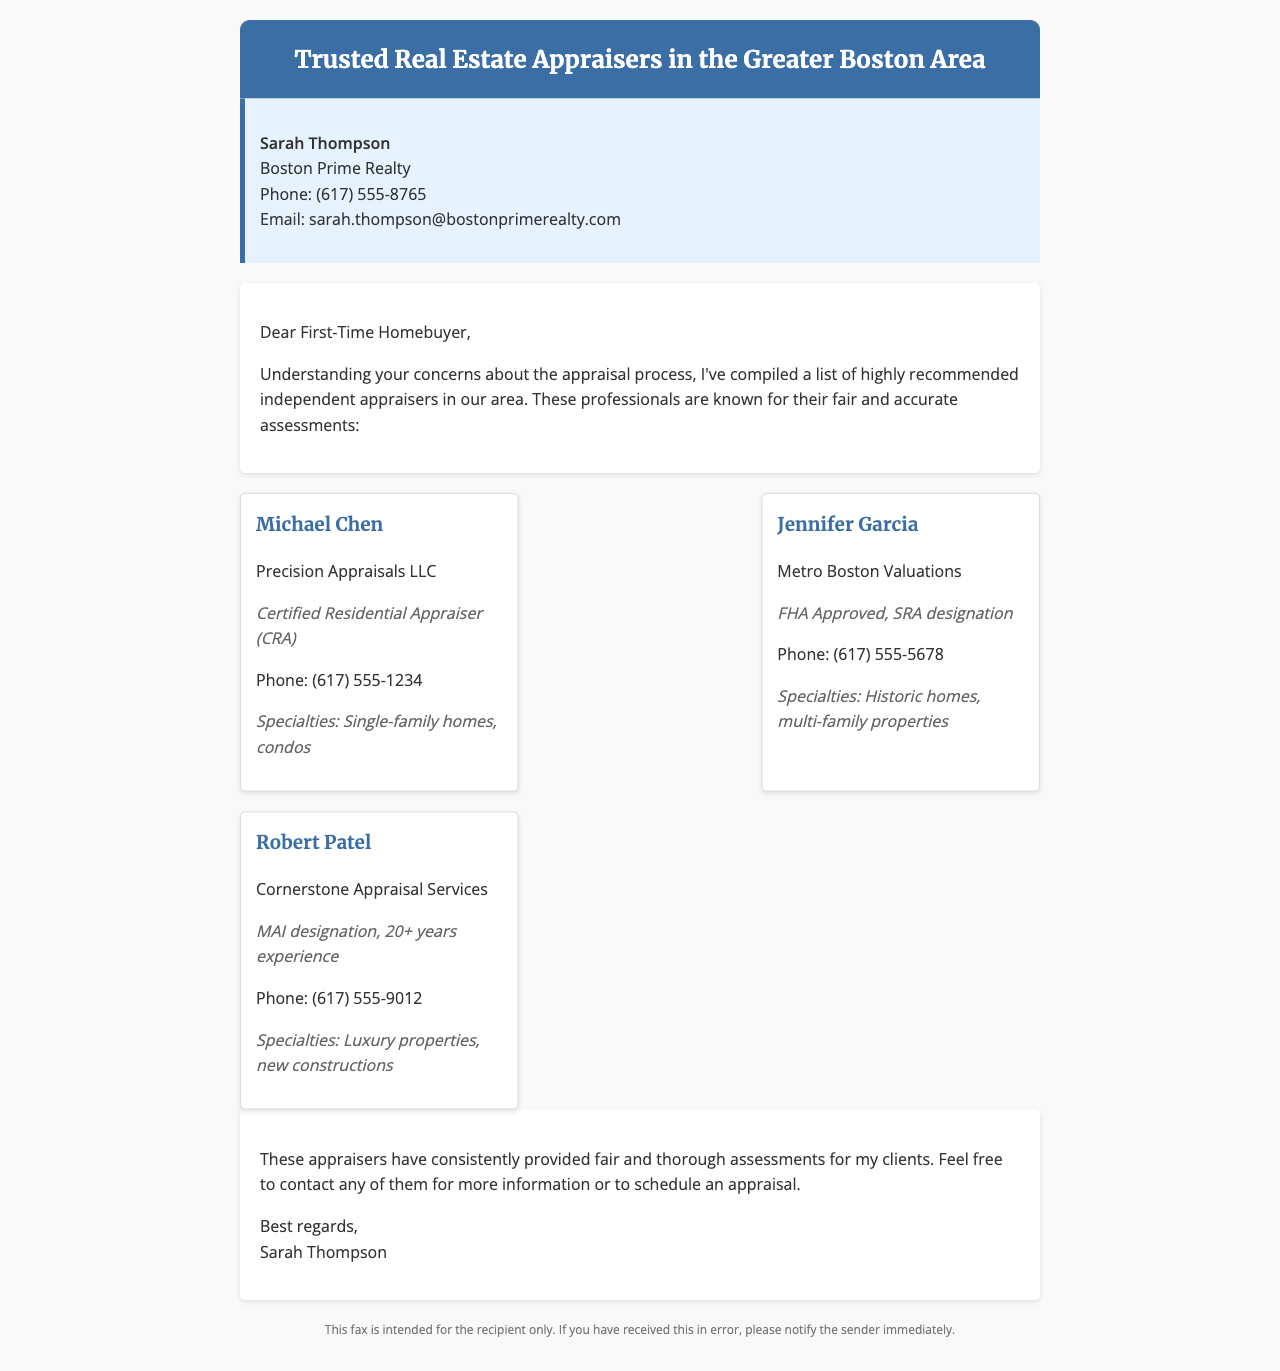What is the title of the document? The title of the document is mentioned in the header, indicating the subject of the fax.
Answer: Trusted Real Estate Appraisers in the Greater Boston Area Who is the real estate agent? The document identifies the person who provided the appraiser list.
Answer: Sarah Thompson What is the phone number for Michael Chen? The document lists contact information for each appraiser.
Answer: (617) 555-1234 What is Jennifer Garcia's specialty? The specialties of the appraisers are noted in their respective sections.
Answer: Historic homes, multi-family properties How many years of experience does Robert Patel have? The document mentions the experience level of Robert Patel as part of his credentials.
Answer: 20+ years What is the company name for Robert Patel? The document specifies the business each appraiser is associated with.
Answer: Cornerstone Appraisal Services What designation does Jennifer Garcia hold? The document provides specific credentials for each appraiser.
Answer: FHA Approved, SRA designation What is the purpose of this fax? The purpose is stated in the introductory text of the document.
Answer: To provide a list of recommended independent appraisers What kind of properties does Michael Chen specialize in? The specialties section provides information on the types of properties each appraiser focuses on.
Answer: Single-family homes, condos 